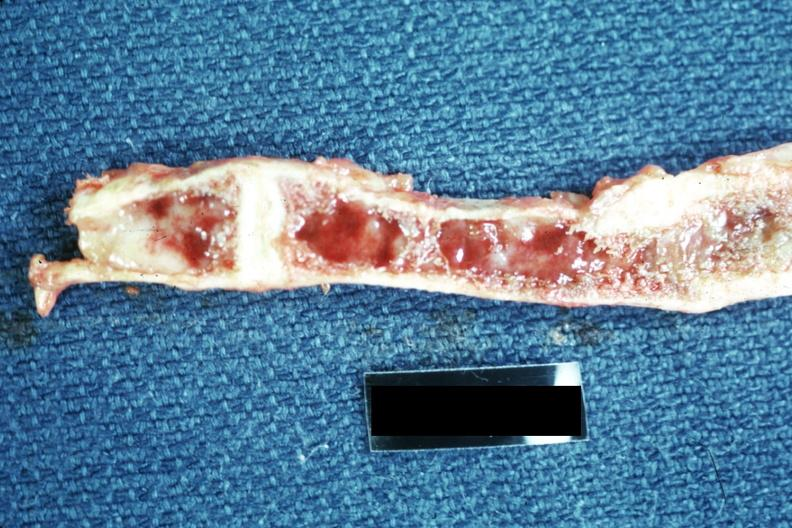does this image show not a good exposure?
Answer the question using a single word or phrase. Yes 